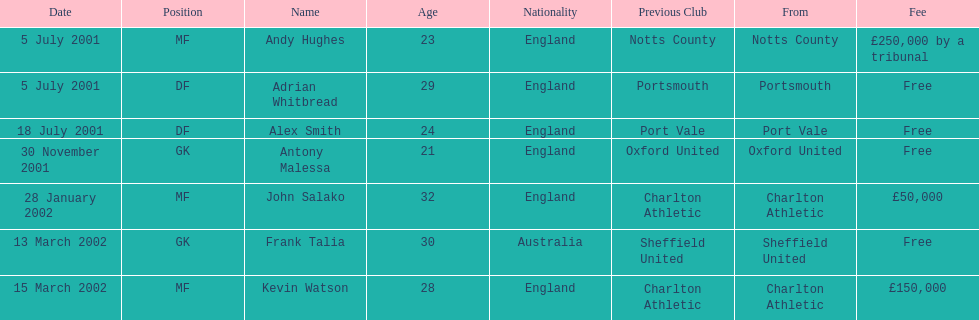Andy huges and adrian whitbread both tranfered on which date? 5 July 2001. 